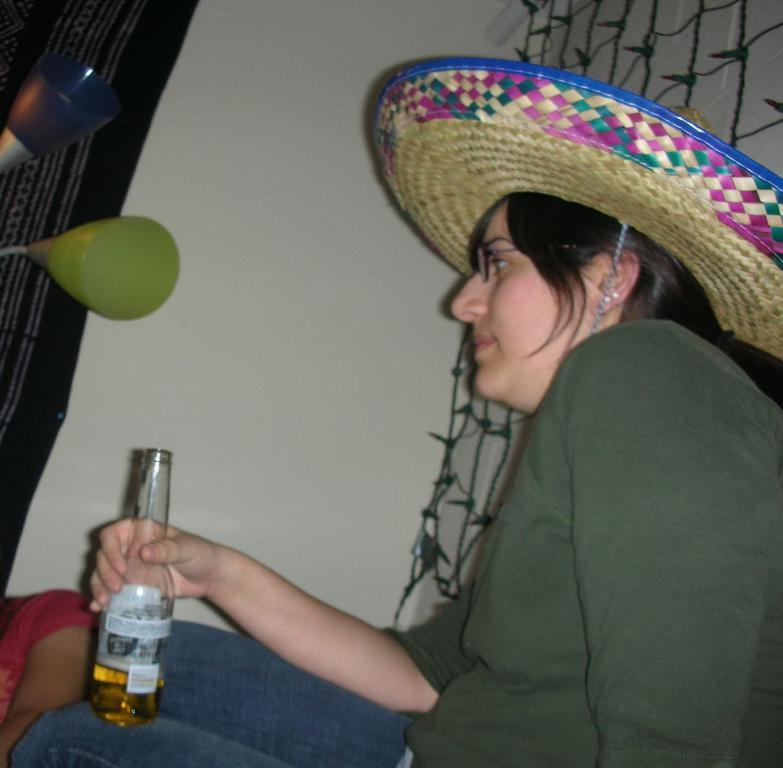Who is present in the image? There is a woman in the image. What is the woman wearing? The woman is wearing a green t-shirt and trousers. What is the woman holding in the image? The woman is holding a bottle. What accessory is the woman wearing? The woman is wearing a hat. Can you describe the background of the image? There is a person, a wall, a net, and cloth visible in the background of the image. What type of grass can be seen growing on the island in the image? There is no island or grass present in the image; it features a woman holding a bottle and various elements in the background. 